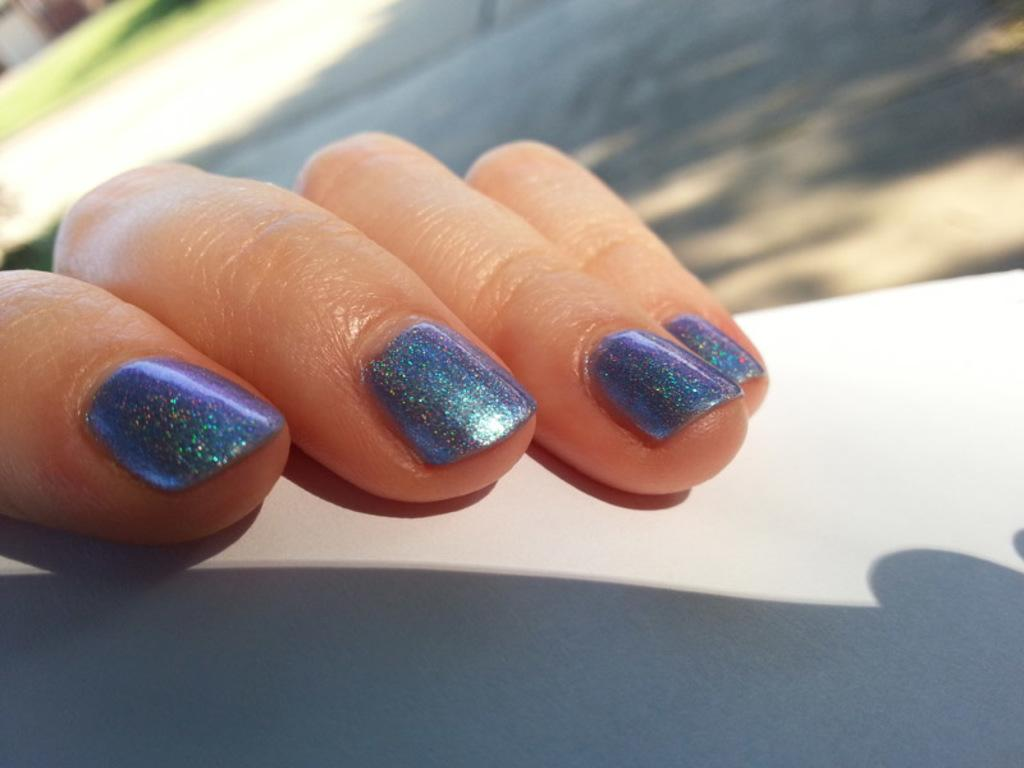What is the main subject of the image? The main subject of the image is fingers on a surface. Can you describe the background of the image? The background of the image is blurred. Reasoning: Let'g: Let's think step by step in order to produce the conversation. We start by identifying the main subject of the image, which is the fingers on a surface. Then, we describe the background of the image, noting that it is blurred. We avoid yes/no questions and ensure that the language is simple and clear. Absurd Question/Answer: What type of camera can be seen in the image? There is no camera present in the image; it features fingers on a surface with a blurred background. What kind of store is visible in the background of the image? There is no store visible in the image; the background is blurred. What type of fog can be seen in the image? There is no fog present in the image; it features fingers on a surface with a blurred background. 